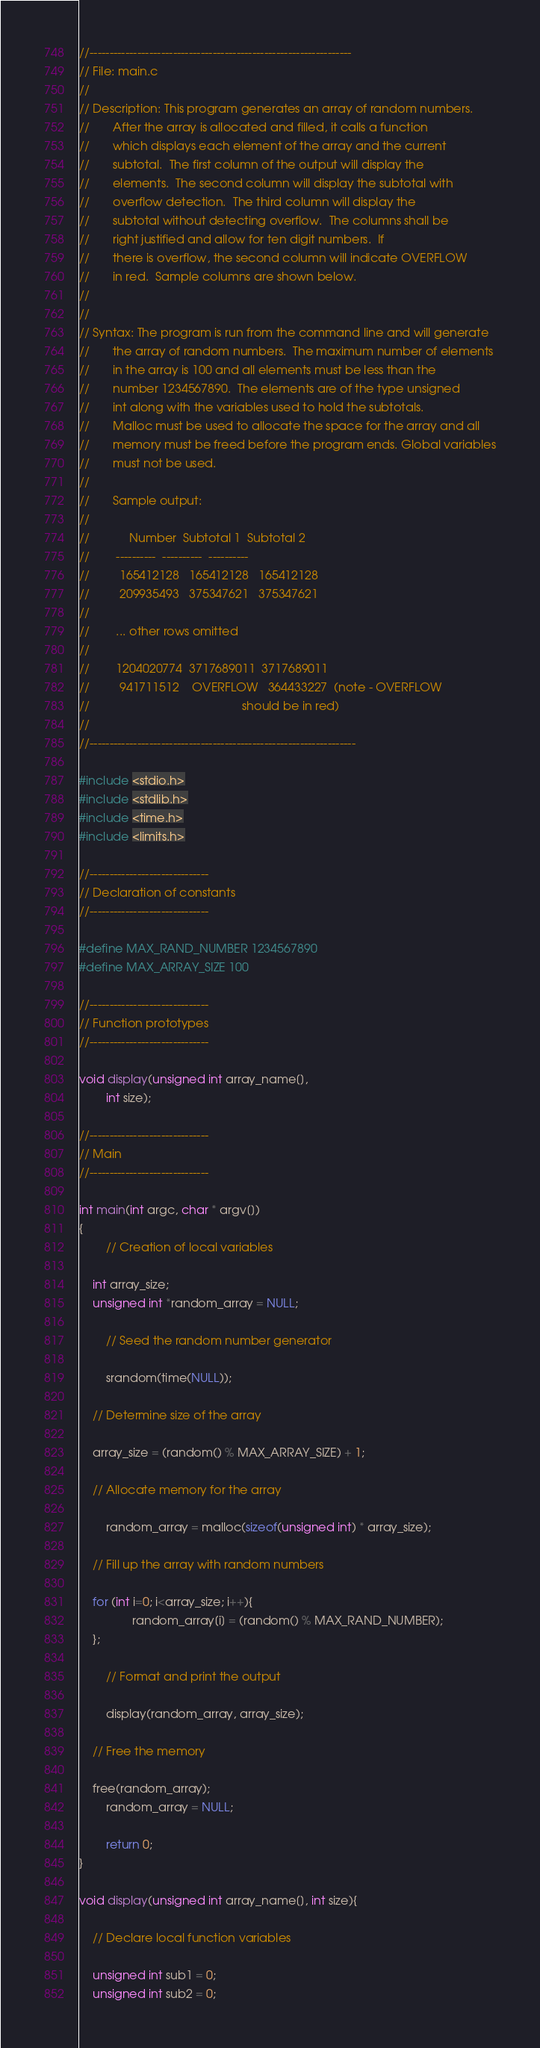<code> <loc_0><loc_0><loc_500><loc_500><_C_>//------------------------------------------------------------------
// File: main.c
//   
// Description: This program generates an array of random numbers.  
//       After the array is allocated and filled, it calls a function
//       which displays each element of the array and the current 
//       subtotal.  The first column of the output will display the 
//       elements.  The second column will display the subtotal with 
//       overflow detection.  The third column will display the 
//       subtotal without detecting overflow.  The columns shall be 
//       right justified and allow for ten digit numbers.  If 
//       there is overflow, the second column will indicate OVERFLOW 
//       in red.  Sample columns are shown below.
//       
//       
// Syntax: The program is run from the command line and will generate 
//       the array of random numbers.  The maximum number of elements
//       in the array is 100 and all elements must be less than the  
//       number 1234567890.  The elements are of the type unsigned
//       int along with the variables used to hold the subtotals.  
//       Malloc must be used to allocate the space for the array and all 
//       memory must be freed before the program ends. Global variables
//       must not be used.  
//       
//       Sample output:
//
//            Number  Subtotal 1  Subtotal 2
//        ----------  ----------  ---------- 
//         165412128   165412128   165412128
//         209935493   375347621   375347621 
//        
//        ... other rows omitted
//              
//        1204020774  3717689011  3717689011   
//         941711512    OVERFLOW   364433227  (note - OVERFLOW 
//                                              should be in red)
//
//-------------------------------------------------------------------

#include <stdio.h>
#include <stdlib.h>
#include <time.h>
#include <limits.h>

//------------------------------
// Declaration of constants
//------------------------------

#define MAX_RAND_NUMBER 1234567890
#define MAX_ARRAY_SIZE 100

//------------------------------
// Function prototypes
//------------------------------

void display(unsigned int array_name[], 
		int size);

//------------------------------
// Main
//------------------------------

int main(int argc, char * argv[])
{
        // Creation of local variables
	
	int array_size;
	unsigned int *random_array = NULL;

        // Seed the random number generator 

        srandom(time(NULL));

	// Determine size of the array
	
	array_size = (random() % MAX_ARRAY_SIZE) + 1;

	// Allocate memory for the array

        random_array = malloc(sizeof(unsigned int) * array_size);

	// Fill up the array with random numbers

	for (int i=0; i<array_size; i++){
                random_array[i] = (random() % MAX_RAND_NUMBER);
	};
	
        // Format and print the output

        display(random_array, array_size);

	// Free the memory
	
	free(random_array);
        random_array = NULL;
		
        return 0;
}

void display(unsigned int array_name[], int size){

	// Declare local function variables
	
	unsigned int sub1 = 0;
	unsigned int sub2 = 0;</code> 